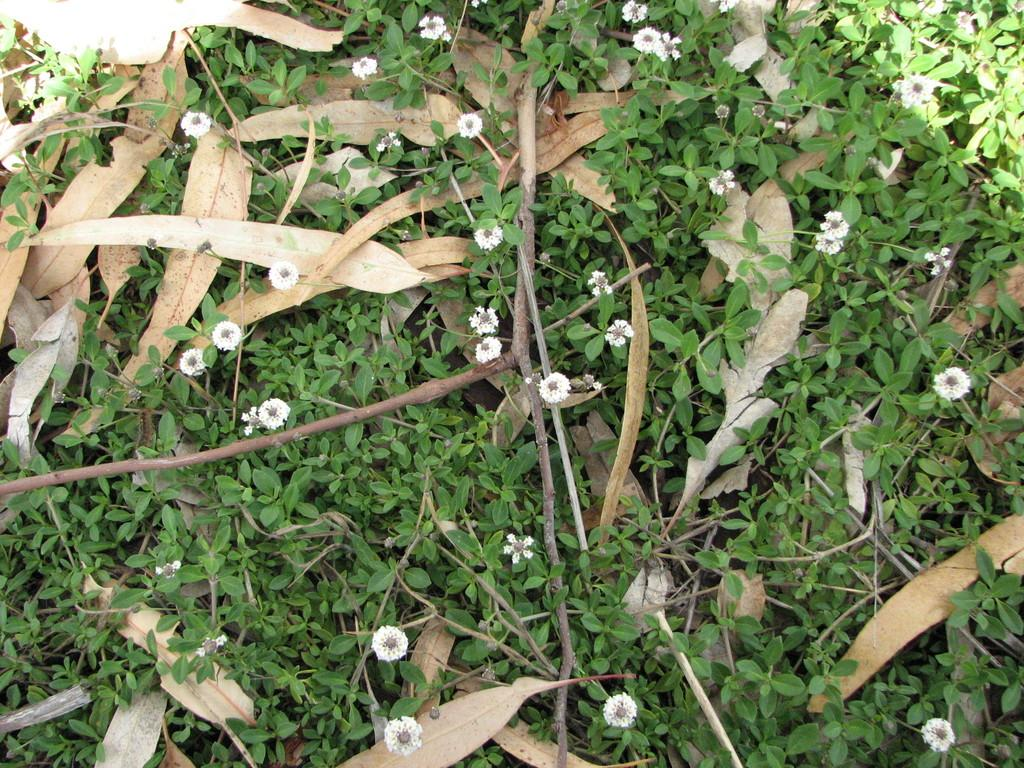What type of vegetation can be seen in the image? There are flowers, twigs, and plants visible in the image. What else is present in the image besides vegetation? Dry leaves are present in the image. What type of apple can be seen in the image? There is no apple present in the image. Can you describe the beetle that is crawling on the flowers in the image? There is no beetle present in the image; only flowers, twigs, plants, and dry leaves are visible. 